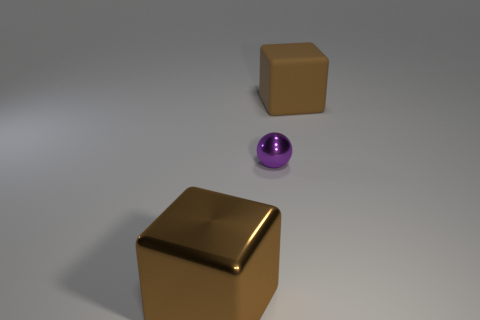Add 3 large red matte cylinders. How many objects exist? 6 Subtract all cubes. How many objects are left? 1 Subtract 1 spheres. How many spheres are left? 0 Subtract all green blocks. Subtract all brown cylinders. How many blocks are left? 2 Subtract all purple spheres. Subtract all small purple shiny balls. How many objects are left? 1 Add 2 purple metallic spheres. How many purple metallic spheres are left? 3 Add 1 cyan matte objects. How many cyan matte objects exist? 1 Subtract 0 brown cylinders. How many objects are left? 3 